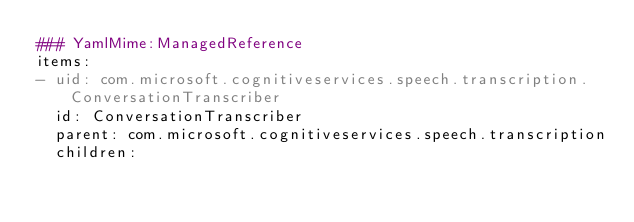<code> <loc_0><loc_0><loc_500><loc_500><_YAML_>### YamlMime:ManagedReference
items:
- uid: com.microsoft.cognitiveservices.speech.transcription.ConversationTranscriber
  id: ConversationTranscriber
  parent: com.microsoft.cognitiveservices.speech.transcription
  children:</code> 